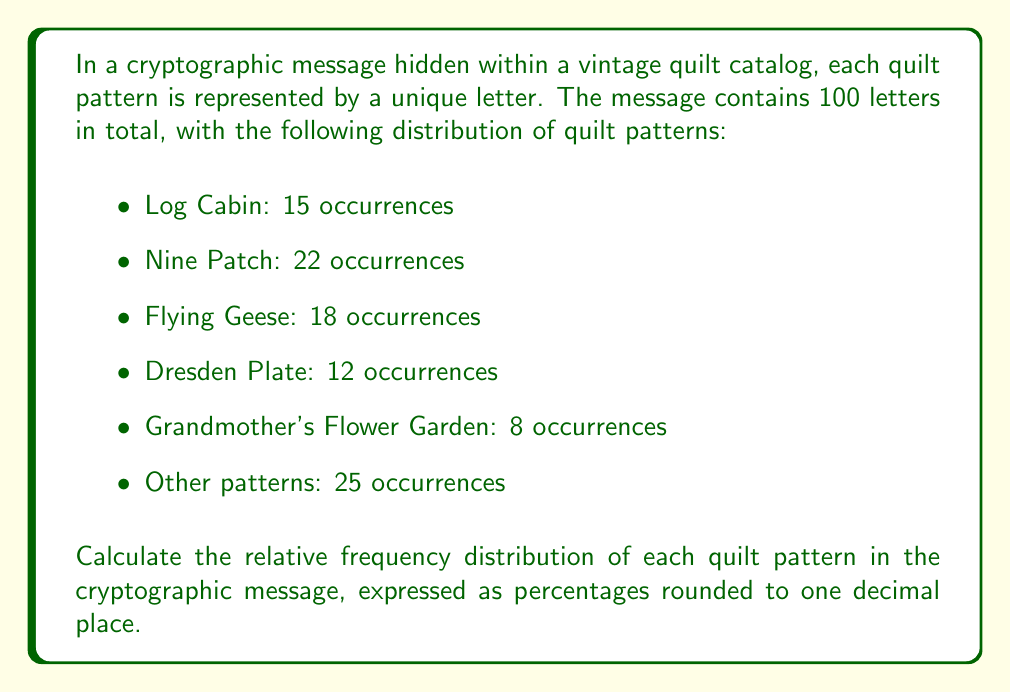Can you solve this math problem? To calculate the relative frequency distribution of quilt patterns in the cryptographic message, we need to follow these steps:

1. Identify the total number of occurrences (sample size):
   $$ \text{Total} = 15 + 22 + 18 + 12 + 8 + 25 = 100 $$

2. Calculate the relative frequency for each pattern using the formula:
   $$ \text{Relative Frequency} = \frac{\text{Number of Occurrences}}{\text{Total Number of Occurrences}} \times 100\% $$

3. Calculate for each pattern:

   Log Cabin:
   $$ \frac{15}{100} \times 100\% = 15.0\% $$

   Nine Patch:
   $$ \frac{22}{100} \times 100\% = 22.0\% $$

   Flying Geese:
   $$ \frac{18}{100} \times 100\% = 18.0\% $$

   Dresden Plate:
   $$ \frac{12}{100} \times 100\% = 12.0\% $$

   Grandmother's Flower Garden:
   $$ \frac{8}{100} \times 100\% = 8.0\% $$

   Other patterns:
   $$ \frac{25}{100} \times 100\% = 25.0\% $$

4. Round all percentages to one decimal place (which in this case doesn't change any values).

The relative frequency distribution represents the proportion of each quilt pattern in the cryptographic message, allowing us to understand the prevalence of each pattern within the encoded information.
Answer: Log Cabin: 15.0%, Nine Patch: 22.0%, Flying Geese: 18.0%, Dresden Plate: 12.0%, Grandmother's Flower Garden: 8.0%, Other patterns: 25.0% 